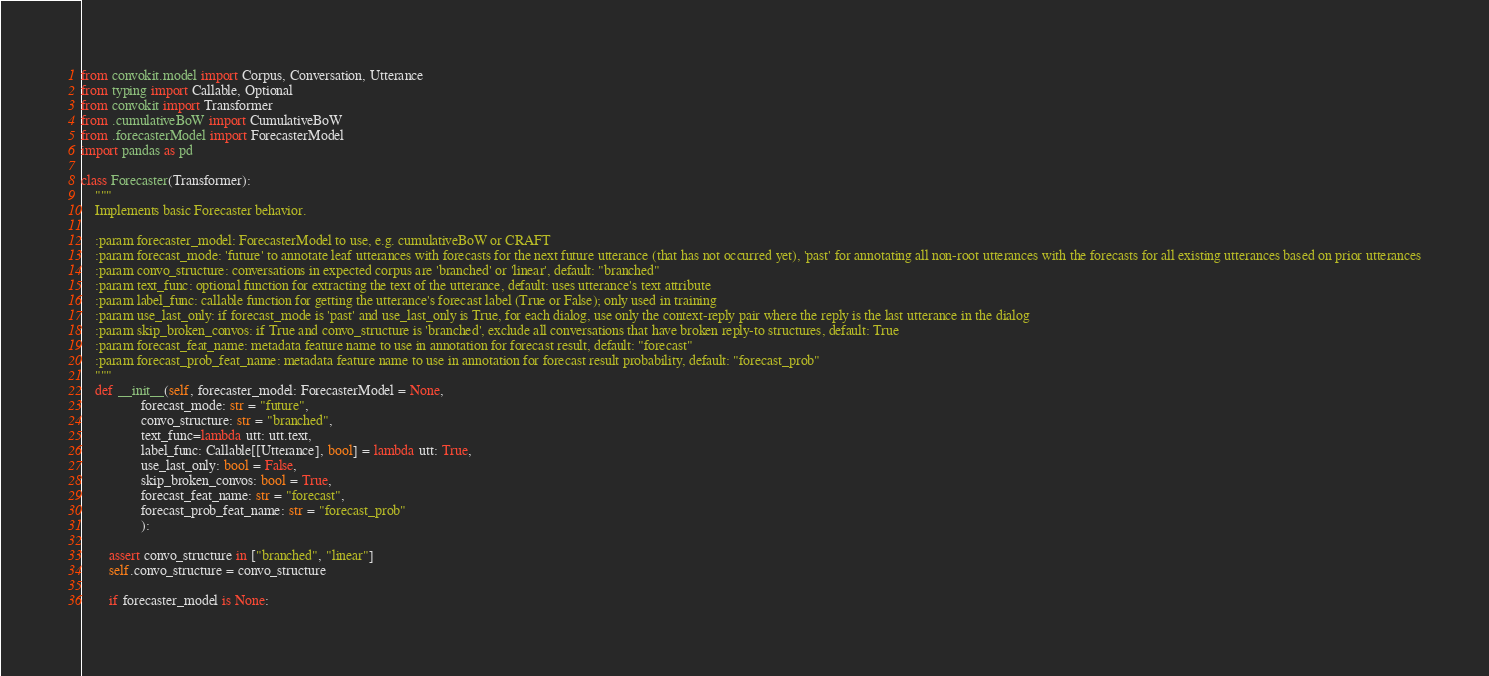Convert code to text. <code><loc_0><loc_0><loc_500><loc_500><_Python_>from convokit.model import Corpus, Conversation, Utterance
from typing import Callable, Optional
from convokit import Transformer
from .cumulativeBoW import CumulativeBoW
from .forecasterModel import ForecasterModel
import pandas as pd

class Forecaster(Transformer):
    """
    Implements basic Forecaster behavior.

    :param forecaster_model: ForecasterModel to use, e.g. cumulativeBoW or CRAFT
    :param forecast_mode: 'future' to annotate leaf utterances with forecasts for the next future utterance (that has not occurred yet), 'past' for annotating all non-root utterances with the forecasts for all existing utterances based on prior utterances
    :param convo_structure: conversations in expected corpus are 'branched' or 'linear', default: "branched"
    :param text_func: optional function for extracting the text of the utterance, default: uses utterance's text attribute
    :param label_func: callable function for getting the utterance's forecast label (True or False); only used in training
    :param use_last_only: if forecast_mode is 'past' and use_last_only is True, for each dialog, use only the context-reply pair where the reply is the last utterance in the dialog
    :param skip_broken_convos: if True and convo_structure is 'branched', exclude all conversations that have broken reply-to structures, default: True
    :param forecast_feat_name: metadata feature name to use in annotation for forecast result, default: "forecast"
    :param forecast_prob_feat_name: metadata feature name to use in annotation for forecast result probability, default: "forecast_prob"
    """
    def __init__(self, forecaster_model: ForecasterModel = None,
                 forecast_mode: str = "future",
                 convo_structure: str = "branched",
                 text_func=lambda utt: utt.text,
                 label_func: Callable[[Utterance], bool] = lambda utt: True,
                 use_last_only: bool = False,
                 skip_broken_convos: bool = True,
                 forecast_feat_name: str = "forecast",
                 forecast_prob_feat_name: str = "forecast_prob"
                 ):

        assert convo_structure in ["branched", "linear"]
        self.convo_structure = convo_structure

        if forecaster_model is None:</code> 